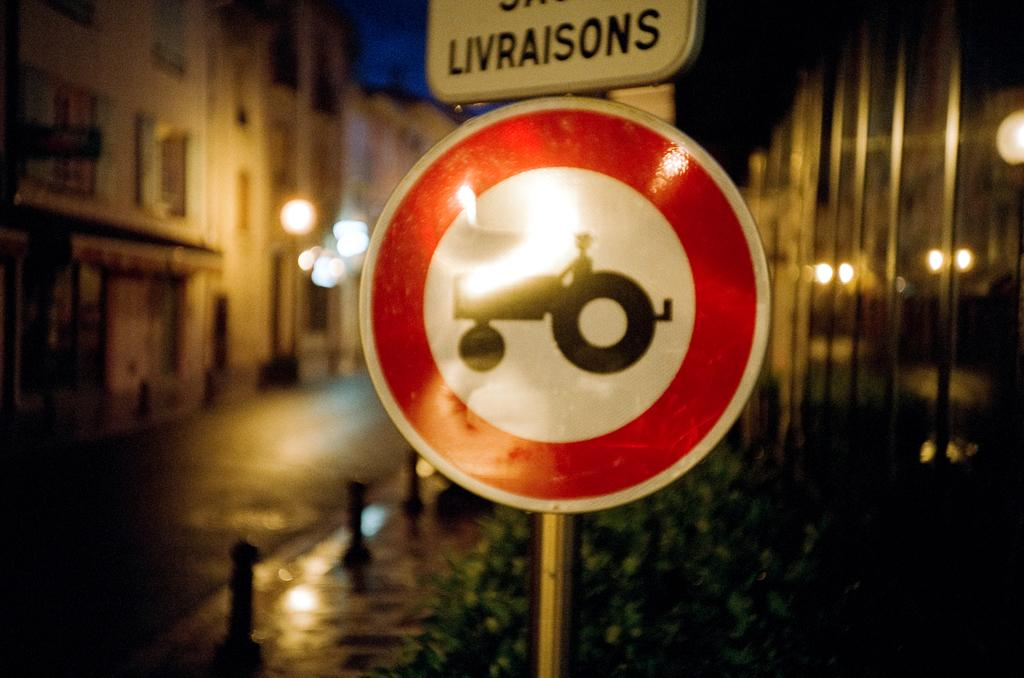<image>
Present a compact description of the photo's key features. a sign for tractors and the word livraisons above it 